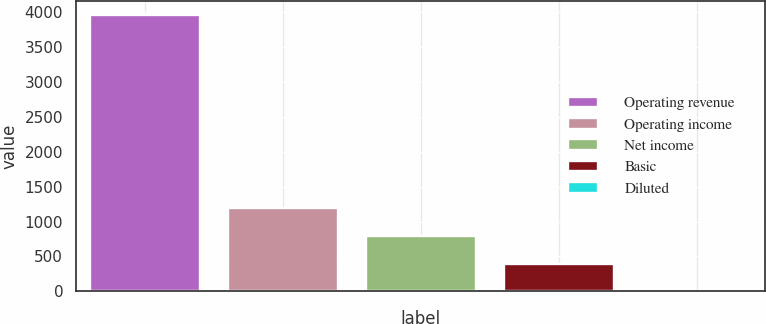Convert chart to OTSL. <chart><loc_0><loc_0><loc_500><loc_500><bar_chart><fcel>Operating revenue<fcel>Operating income<fcel>Net income<fcel>Basic<fcel>Diluted<nl><fcel>3962<fcel>1189.84<fcel>793.82<fcel>397.8<fcel>1.78<nl></chart> 